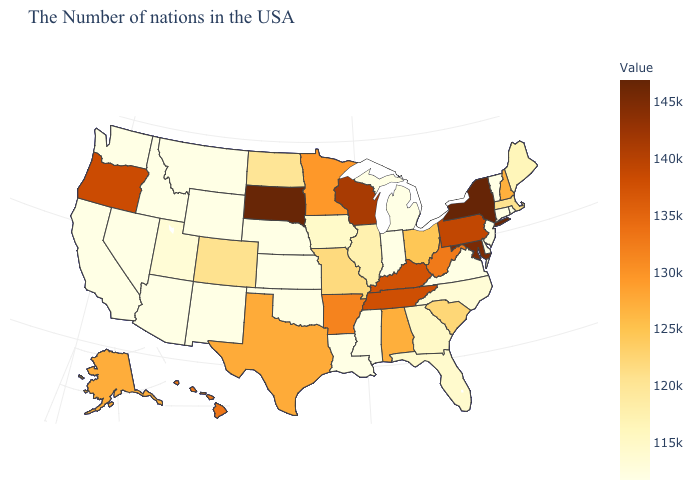Does Arizona have a lower value than New Hampshire?
Write a very short answer. Yes. Does Idaho have the lowest value in the West?
Write a very short answer. Yes. Which states have the lowest value in the MidWest?
Keep it brief. Michigan, Indiana, Kansas, Nebraska. Which states hav the highest value in the West?
Answer briefly. Oregon. Which states hav the highest value in the Northeast?
Be succinct. New York. 